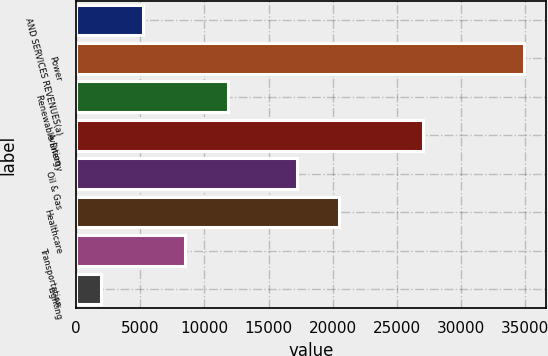<chart> <loc_0><loc_0><loc_500><loc_500><bar_chart><fcel>AND SERVICES REVENUES(a)<fcel>Power<fcel>Renewable Energy<fcel>Aviation<fcel>Oil & Gas<fcel>Healthcare<fcel>Transportation<fcel>Lighting<nl><fcel>5234.7<fcel>34878<fcel>11822.1<fcel>27013<fcel>17180<fcel>20473.7<fcel>8528.4<fcel>1941<nl></chart> 